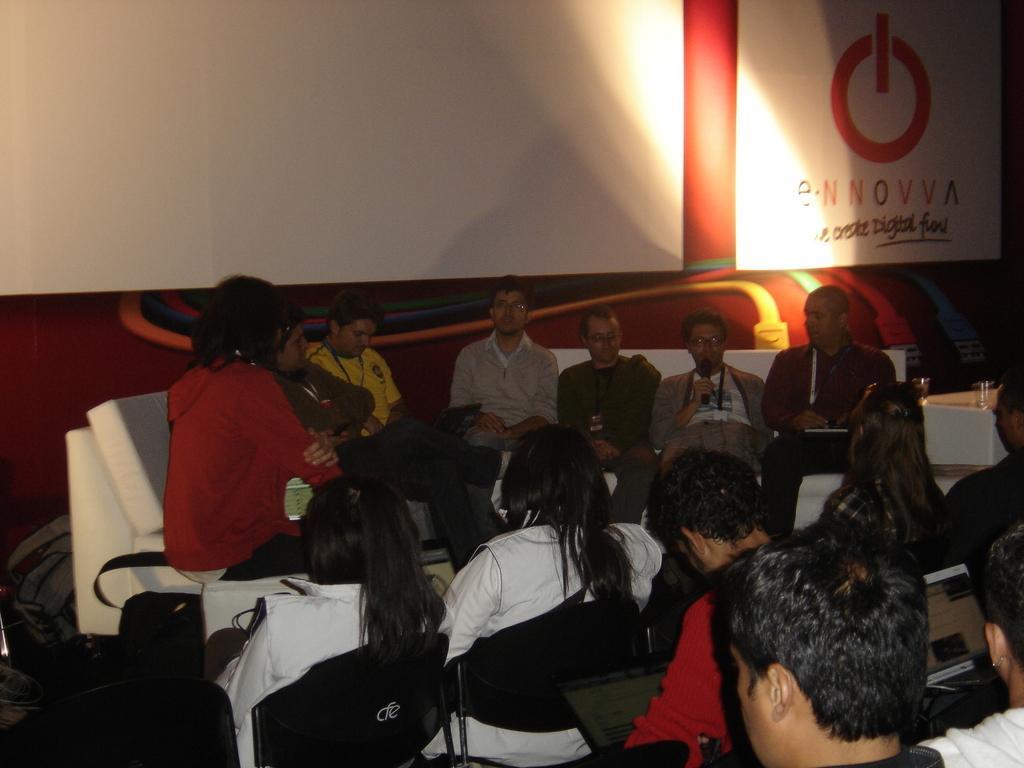How would you summarize this image in a sentence or two? In this image there are many people sitting on the chairs. In the center there is a man holding a microphone in his hand. To the right there is a table. There are glasses on the table. Behind them there is a wall. There are boards hanging on the wall. To the left there are bags on the floor. 